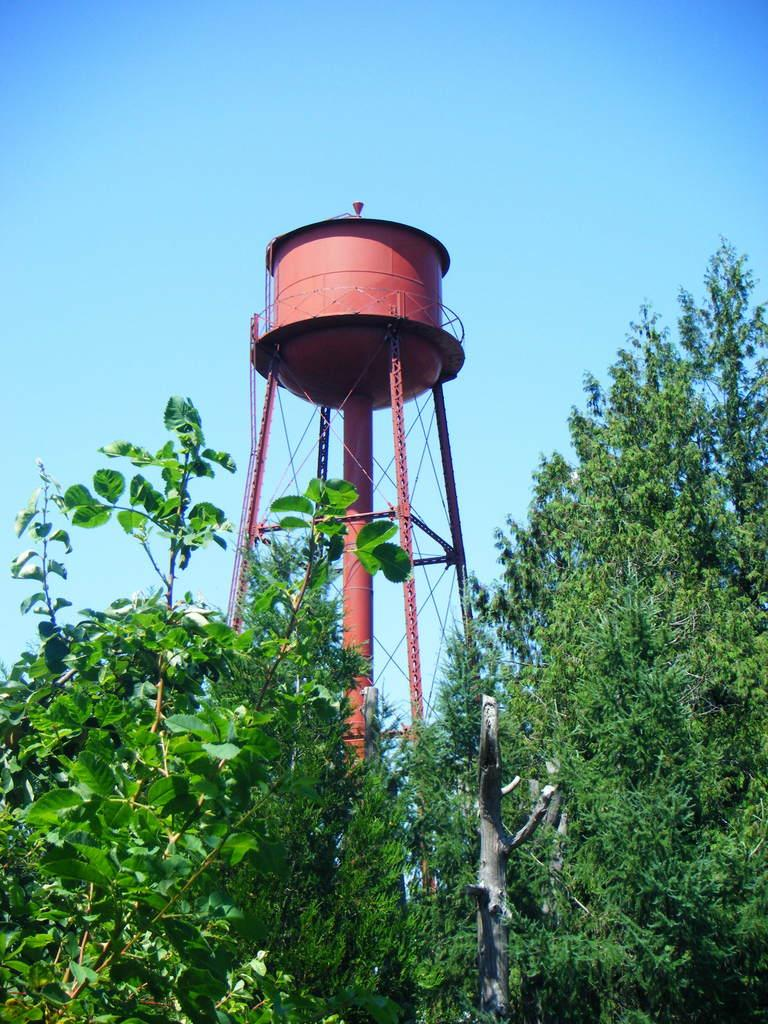What type of vegetation is present in the image? There are trees in the image. What is the color of the trees? The trees are green in color. What structure can be seen in the image besides the trees? There is a tower in the image. What is the color of the tower? The tower is brown in color. What is on top of the tower? There is a water tank on the tower. What can be seen in the background of the image? The sky is visible in the background of the image. What type of jelly is being used to decorate the tower in the image? There is no jelly present in the image, and the tower is not being decorated with any jelly. What songs are being sung by the trees in the image? Trees do not sing songs, and there are no songs being sung in the image. 